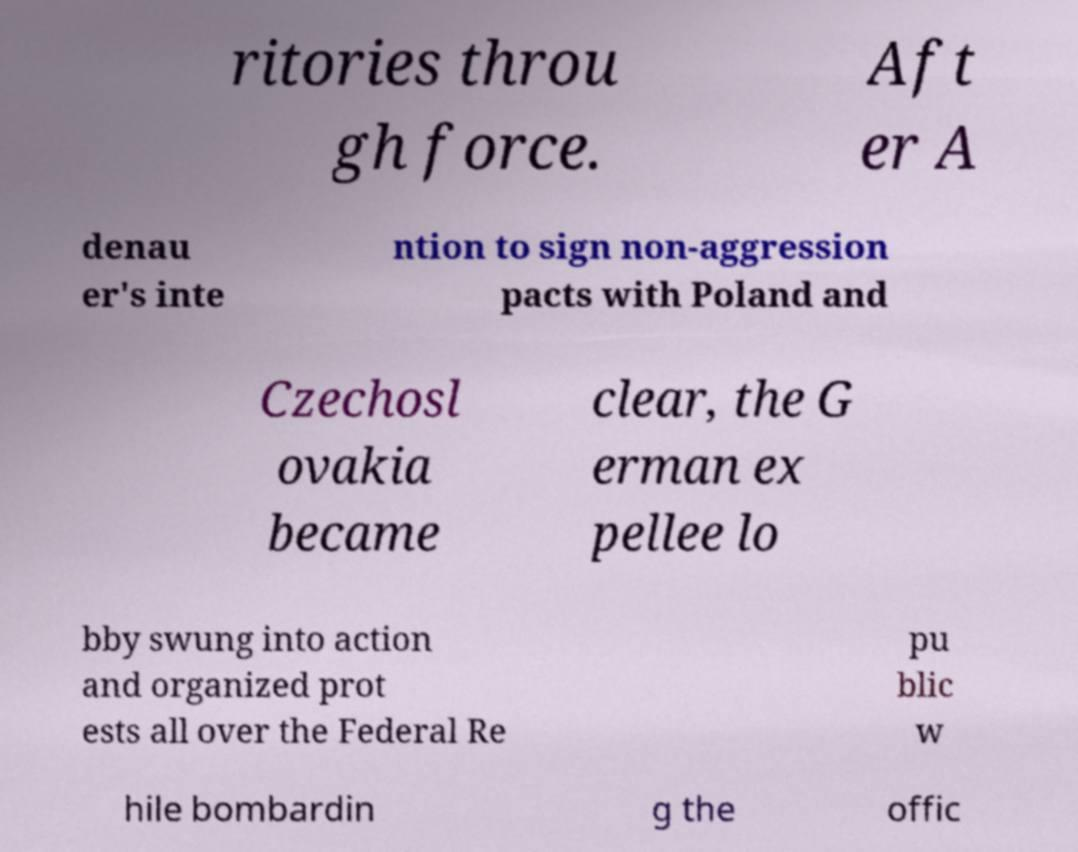There's text embedded in this image that I need extracted. Can you transcribe it verbatim? ritories throu gh force. Aft er A denau er's inte ntion to sign non-aggression pacts with Poland and Czechosl ovakia became clear, the G erman ex pellee lo bby swung into action and organized prot ests all over the Federal Re pu blic w hile bombardin g the offic 